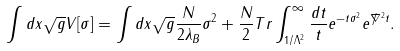Convert formula to latex. <formula><loc_0><loc_0><loc_500><loc_500>\int d x \sqrt { g } V [ \sigma ] = \int d x \sqrt { g } \frac { N } { 2 \lambda _ { B } } \sigma ^ { 2 } + \frac { N } { 2 } T r \int _ { 1 / \Lambda ^ { 2 } } ^ { \infty } \frac { d t } { t } e ^ { - t \sigma ^ { 2 } } e ^ { \not \nabla ^ { 2 } t } .</formula> 